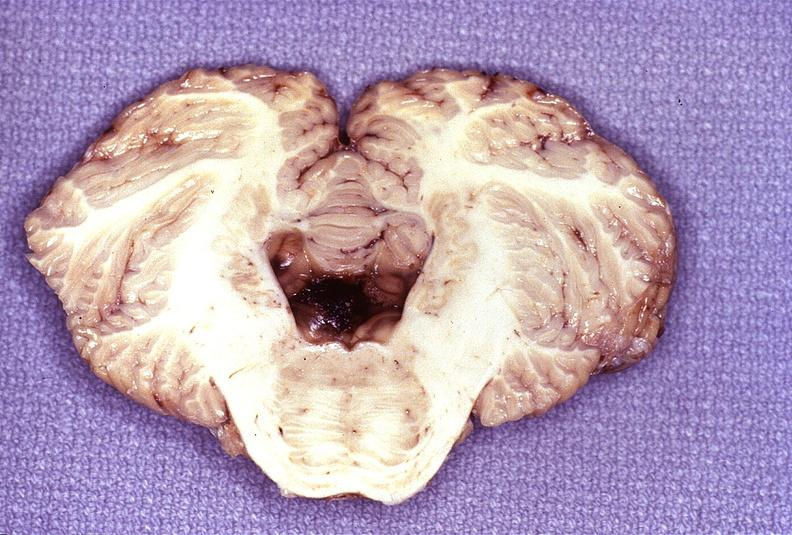s splenomegaly with cirrhosis present?
Answer the question using a single word or phrase. No 